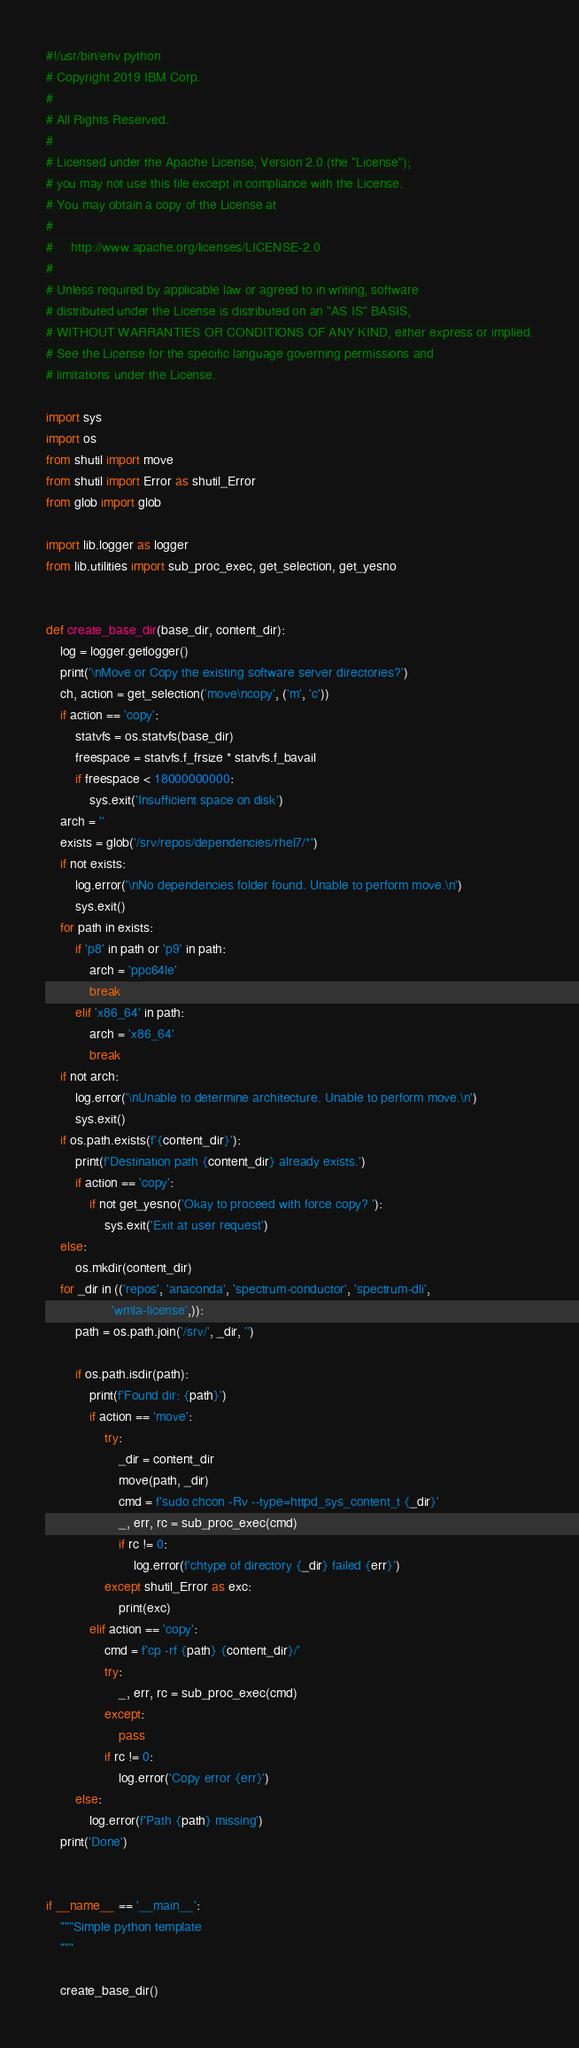<code> <loc_0><loc_0><loc_500><loc_500><_Python_>#!/usr/bin/env python
# Copyright 2019 IBM Corp.
#
# All Rights Reserved.
#
# Licensed under the Apache License, Version 2.0 (the "License");
# you may not use this file except in compliance with the License.
# You may obtain a copy of the License at
#
#     http://www.apache.org/licenses/LICENSE-2.0
#
# Unless required by applicable law or agreed to in writing, software
# distributed under the License is distributed on an "AS IS" BASIS,
# WITHOUT WARRANTIES OR CONDITIONS OF ANY KIND, either express or implied.
# See the License for the specific language governing permissions and
# limitations under the License.

import sys
import os
from shutil import move
from shutil import Error as shutil_Error
from glob import glob

import lib.logger as logger
from lib.utilities import sub_proc_exec, get_selection, get_yesno


def create_base_dir(base_dir, content_dir):
    log = logger.getlogger()
    print('\nMove or Copy the existing software server directories?')
    ch, action = get_selection('move\ncopy', ('m', 'c'))
    if action == 'copy':
        statvfs = os.statvfs(base_dir)
        freespace = statvfs.f_frsize * statvfs.f_bavail
        if freespace < 18000000000:
            sys.exit('Insufficient space on disk')
    arch = ''
    exists = glob('/srv/repos/dependencies/rhel7/*')
    if not exists:
        log.error('\nNo dependencies folder found. Unable to perform move.\n')
        sys.exit()
    for path in exists:
        if 'p8' in path or 'p9' in path:
            arch = 'ppc64le'
            break
        elif 'x86_64' in path:
            arch = 'x86_64'
            break
    if not arch:
        log.error('\nUnable to determine architecture. Unable to perform move.\n')
        sys.exit()
    if os.path.exists(f'{content_dir}'):
        print(f'Destination path {content_dir} already exists.')
        if action == 'copy':
            if not get_yesno('Okay to proceed with force copy? '):
                sys.exit('Exit at user request')
    else:
        os.mkdir(content_dir)
    for _dir in (('repos', 'anaconda', 'spectrum-conductor', 'spectrum-dli',
                  'wmla-license',)):
        path = os.path.join('/srv/', _dir, '')

        if os.path.isdir(path):
            print(f'Found dir: {path}')
            if action == 'move':
                try:
                    _dir = content_dir
                    move(path, _dir)
                    cmd = f'sudo chcon -Rv --type=httpd_sys_content_t {_dir}'
                    _, err, rc = sub_proc_exec(cmd)
                    if rc != 0:
                        log.error(f'chtype of directory {_dir} failed {err}')
                except shutil_Error as exc:
                    print(exc)
            elif action == 'copy':
                cmd = f'cp -rf {path} {content_dir}/'
                try:
                    _, err, rc = sub_proc_exec(cmd)
                except:
                    pass
                if rc != 0:
                    log.error('Copy error {err}')
        else:
            log.error(f'Path {path} missing')
    print('Done')


if __name__ == '__main__':
    """Simple python template
    """

    create_base_dir()
</code> 